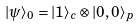Convert formula to latex. <formula><loc_0><loc_0><loc_500><loc_500>| \psi \rangle _ { 0 } = | 1 \rangle _ { c } \otimes | 0 , 0 \rangle _ { p }</formula> 